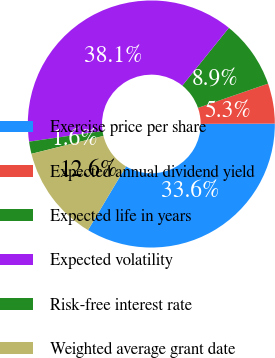<chart> <loc_0><loc_0><loc_500><loc_500><pie_chart><fcel>Exercise price per share<fcel>Expected annual dividend yield<fcel>Expected life in years<fcel>Expected volatility<fcel>Risk-free interest rate<fcel>Weighted average grant date<nl><fcel>33.61%<fcel>5.25%<fcel>8.9%<fcel>38.08%<fcel>1.6%<fcel>12.55%<nl></chart> 